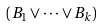Convert formula to latex. <formula><loc_0><loc_0><loc_500><loc_500>( B _ { 1 } \vee \cdot \cdot \cdot \vee B _ { k } )</formula> 